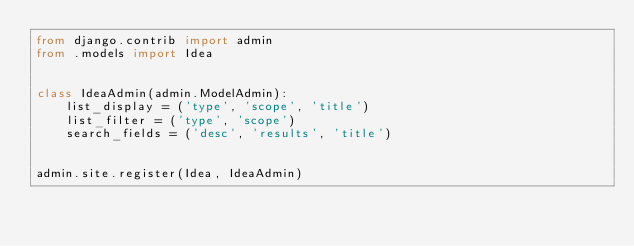<code> <loc_0><loc_0><loc_500><loc_500><_Python_>from django.contrib import admin
from .models import Idea


class IdeaAdmin(admin.ModelAdmin):
    list_display = ('type', 'scope', 'title')
    list_filter = ('type', 'scope')
    search_fields = ('desc', 'results', 'title')


admin.site.register(Idea, IdeaAdmin)
</code> 